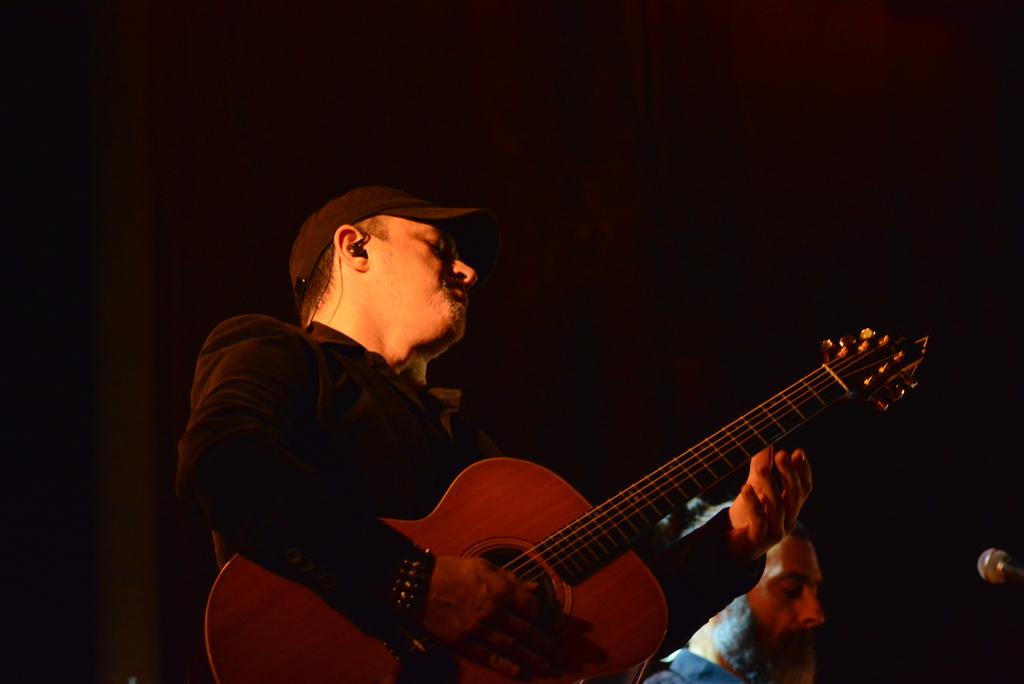What is the main activity being performed by the person in the image? There is a person playing a guitar in the image. Can you describe the appearance of the person playing the guitar? The person is wearing a cap. Is there anyone else in the image besides the guitar player? Yes, there is another person beside the guitar player. What object is present in front of the two people? There is a microphone in front of the two people. What type of seed is being planted by the person playing the guitar in the image? There is no seed or planting activity present in the image; the person is playing a guitar. 